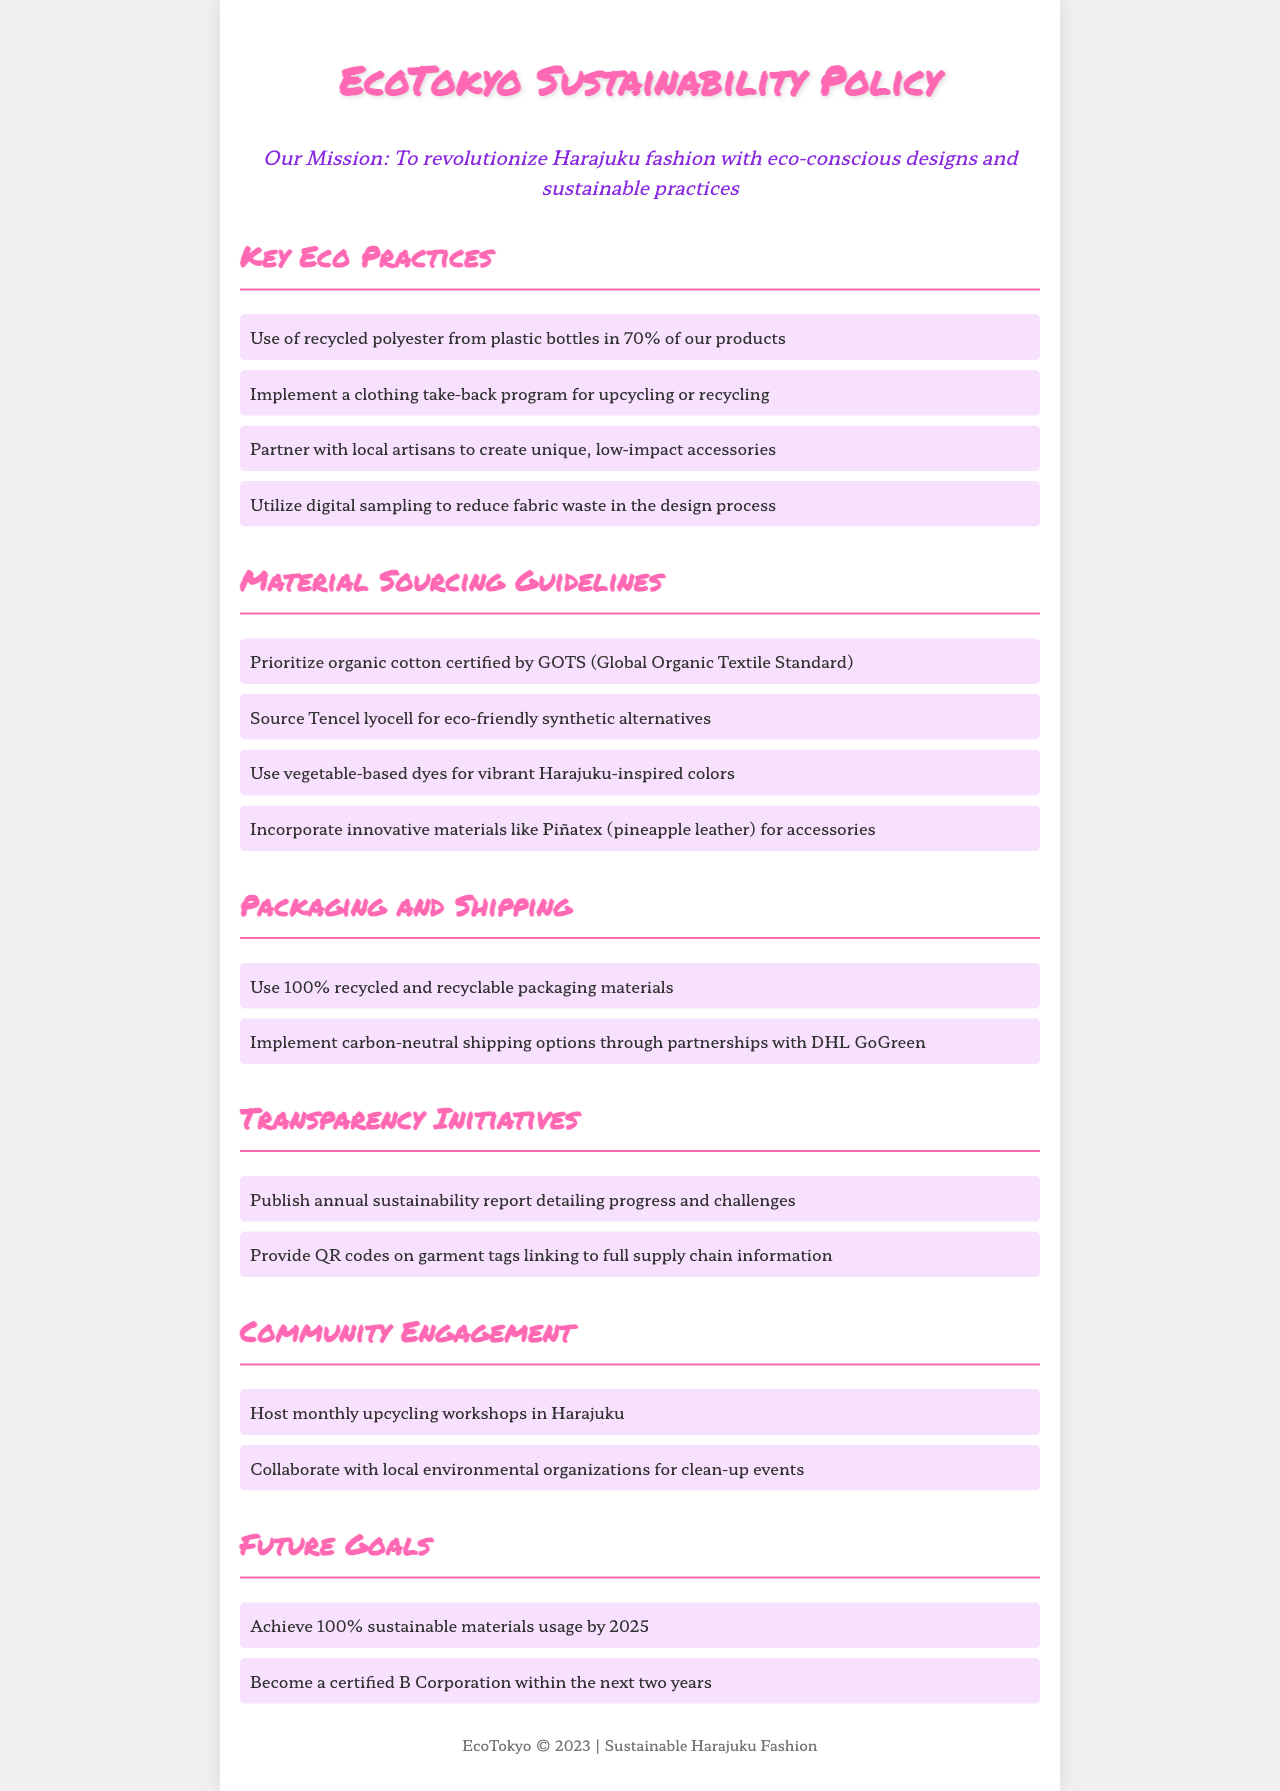What is EcoTokyo's mission? The mission is outlined in a sentence that highlights the commitment to eco-conscious designs and sustainable practices in Harajuku fashion.
Answer: To revolutionize Harajuku fashion with eco-conscious designs and sustainable practices What percentage of products use recycled polyester? This information can be found in the section detailing key eco practices, specifically mentioning the use of recycled materials.
Answer: 70% What material is prioritized according to the sourcing guidelines? The sourcing guidelines list specific materials, and organic cotton is specifically noted as a prioritized choice.
Answer: Organic cotton What type of workshops are hosted monthly in Harajuku? The community engagement section provides details about activities and types of workshops organized in the area.
Answer: Upcycling workshops What shipping option is implemented by EcoTokyo? The policy mentions specific shipping practices within the Packaging and Shipping section, particularly focusing on sustainability.
Answer: Carbon-neutral shipping options What innovative material is mentioned for accessories? The material sourcing guidelines refer to specific innovative materials, including one that comes from pineapples.
Answer: Piñatex What is EcoTokyo's goal for sustainable materials by 2025? This goal is specified in a section dedicated to future plans and targets for sustainability.
Answer: 100% sustainable materials usage When does EcoTokyo aim to become a certified B Corporation? The future goals section includes a timeline for certification, indicating the specific timeframe set by EcoTokyo.
Answer: Within the next two years 